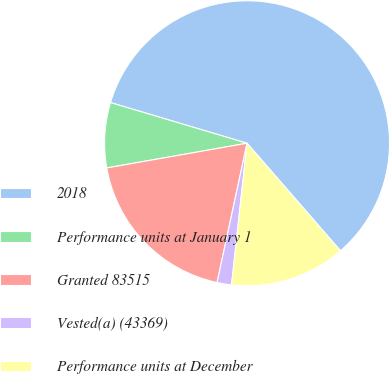<chart> <loc_0><loc_0><loc_500><loc_500><pie_chart><fcel>2018<fcel>Performance units at January 1<fcel>Granted 83515<fcel>Vested(a) (43369)<fcel>Performance units at December<nl><fcel>59.01%<fcel>7.38%<fcel>18.85%<fcel>1.64%<fcel>13.12%<nl></chart> 